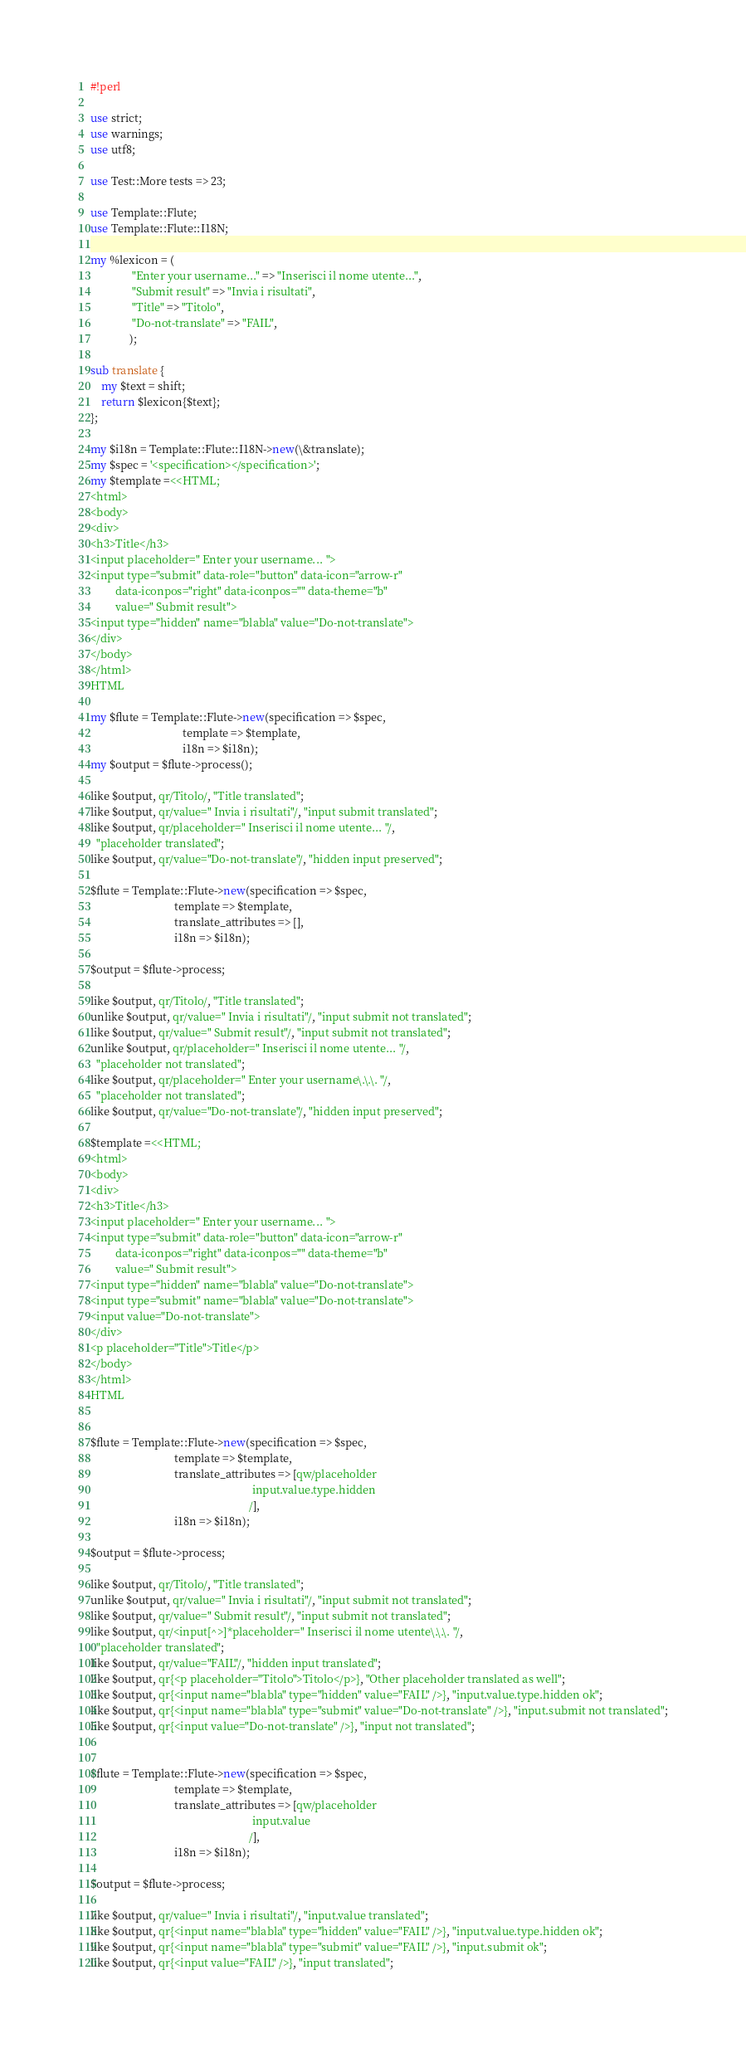Convert code to text. <code><loc_0><loc_0><loc_500><loc_500><_Perl_>#!perl

use strict;
use warnings;
use utf8;

use Test::More tests => 23;

use Template::Flute;
use Template::Flute::I18N;

my %lexicon = (
               "Enter your username..." => "Inserisci il nome utente...",
               "Submit result" => "Invia i risultati",
               "Title" => "Titolo",
               "Do-not-translate" => "FAIL",
              );

sub translate {
    my $text = shift;
    return $lexicon{$text};
};

my $i18n = Template::Flute::I18N->new(\&translate);
my $spec = '<specification></specification>';
my $template =<<HTML;
<html>
<body>
<div>
<h3>Title</h3>
<input placeholder=" Enter your username... ">
<input type="submit" data-role="button" data-icon="arrow-r"
         data-iconpos="right" data-iconpos="" data-theme="b"
         value=" Submit result">
<input type="hidden" name="blabla" value="Do-not-translate">
</div>
</body>
</html>
HTML

my $flute = Template::Flute->new(specification => $spec,
                                 template => $template,
                                 i18n => $i18n);
my $output = $flute->process();

like $output, qr/Titolo/, "Title translated";
like $output, qr/value=" Invia i risultati"/, "input submit translated";
like $output, qr/placeholder=" Inserisci il nome utente... "/,
  "placeholder translated";
like $output, qr/value="Do-not-translate"/, "hidden input preserved";

$flute = Template::Flute->new(specification => $spec,
                              template => $template,
                              translate_attributes => [],
                              i18n => $i18n);

$output = $flute->process;

like $output, qr/Titolo/, "Title translated";
unlike $output, qr/value=" Invia i risultati"/, "input submit not translated";
like $output, qr/value=" Submit result"/, "input submit not translated";
unlike $output, qr/placeholder=" Inserisci il nome utente... "/,
  "placeholder not translated";
like $output, qr/placeholder=" Enter your username\.\.\. "/,
  "placeholder not translated";
like $output, qr/value="Do-not-translate"/, "hidden input preserved";

$template =<<HTML;
<html>
<body>
<div>
<h3>Title</h3>
<input placeholder=" Enter your username... ">
<input type="submit" data-role="button" data-icon="arrow-r"
         data-iconpos="right" data-iconpos="" data-theme="b"
         value=" Submit result">
<input type="hidden" name="blabla" value="Do-not-translate">
<input type="submit" name="blabla" value="Do-not-translate">
<input value="Do-not-translate">
</div>
<p placeholder="Title">Title</p>
</body>
</html>
HTML


$flute = Template::Flute->new(specification => $spec,
                              template => $template,
                              translate_attributes => [qw/placeholder
                                                          input.value.type.hidden
                                                         /],
                              i18n => $i18n);

$output = $flute->process;

like $output, qr/Titolo/, "Title translated";
unlike $output, qr/value=" Invia i risultati"/, "input submit not translated";
like $output, qr/value=" Submit result"/, "input submit not translated";
like $output, qr/<input[^>]*placeholder=" Inserisci il nome utente\.\.\. "/,
  "placeholder translated";
like $output, qr/value="FAIL"/, "hidden input translated";
like $output, qr{<p placeholder="Titolo">Titolo</p>}, "Other placeholder translated as well";
like $output, qr{<input name="blabla" type="hidden" value="FAIL" />}, "input.value.type.hidden ok";
like $output, qr{<input name="blabla" type="submit" value="Do-not-translate" />}, "input.submit not translated";
like $output, qr{<input value="Do-not-translate" />}, "input not translated";


$flute = Template::Flute->new(specification => $spec,
                              template => $template,
                              translate_attributes => [qw/placeholder
                                                          input.value
                                                         /],
                              i18n => $i18n);

$output = $flute->process;

like $output, qr/value=" Invia i risultati"/, "input.value translated";
like $output, qr{<input name="blabla" type="hidden" value="FAIL" />}, "input.value.type.hidden ok";
like $output, qr{<input name="blabla" type="submit" value="FAIL" />}, "input.submit ok";
like $output, qr{<input value="FAIL" />}, "input translated";
</code> 